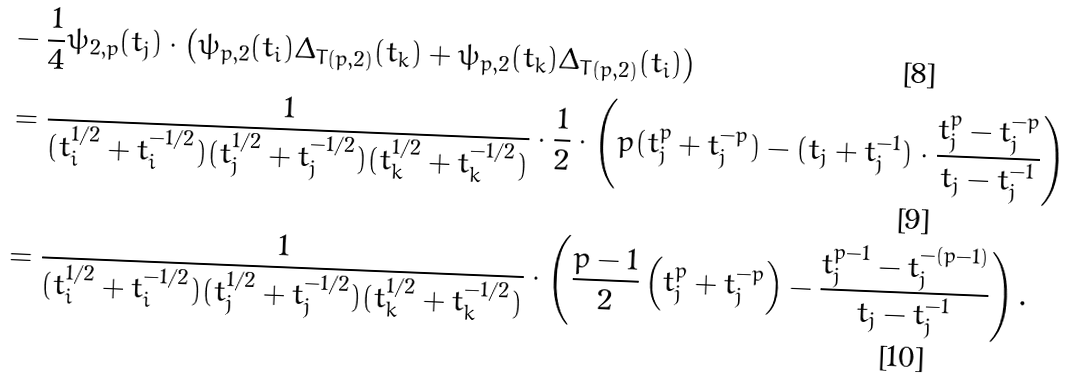<formula> <loc_0><loc_0><loc_500><loc_500>& - \frac { 1 } { 4 } \psi _ { 2 , p } ( t _ { j } ) \cdot \left ( \psi _ { p , 2 } ( t _ { i } ) \Delta _ { T ( p , 2 ) } ( t _ { k } ) + \psi _ { p , 2 } ( t _ { k } ) \Delta _ { T ( p , 2 ) } ( t _ { i } ) \right ) \\ & = \frac { 1 } { ( t _ { i } ^ { 1 / 2 } + t _ { i } ^ { - 1 / 2 } ) ( t _ { j } ^ { 1 / 2 } + t _ { j } ^ { - 1 / 2 } ) ( t _ { k } ^ { 1 / 2 } + t _ { k } ^ { - 1 / 2 } ) } \cdot \frac { 1 } { 2 } \cdot \left ( p ( t _ { j } ^ { p } + t _ { j } ^ { - p } ) - ( t _ { j } + t _ { j } ^ { - 1 } ) \cdot \frac { t _ { j } ^ { p } - t _ { j } ^ { - p } } { t _ { j } - t _ { j } ^ { - 1 } } \right ) \\ & = \frac { 1 } { ( t _ { i } ^ { 1 / 2 } + t _ { i } ^ { - 1 / 2 } ) ( t _ { j } ^ { 1 / 2 } + t _ { j } ^ { - 1 / 2 } ) ( t _ { k } ^ { 1 / 2 } + t _ { k } ^ { - 1 / 2 } ) } \cdot \left ( \frac { p - 1 } 2 \left ( t _ { j } ^ { p } + t _ { j } ^ { - p } \right ) - \frac { t _ { j } ^ { p - 1 } - t _ { j } ^ { - ( p - 1 ) } } { t _ { j } - t _ { j } ^ { - 1 } } \right ) .</formula> 